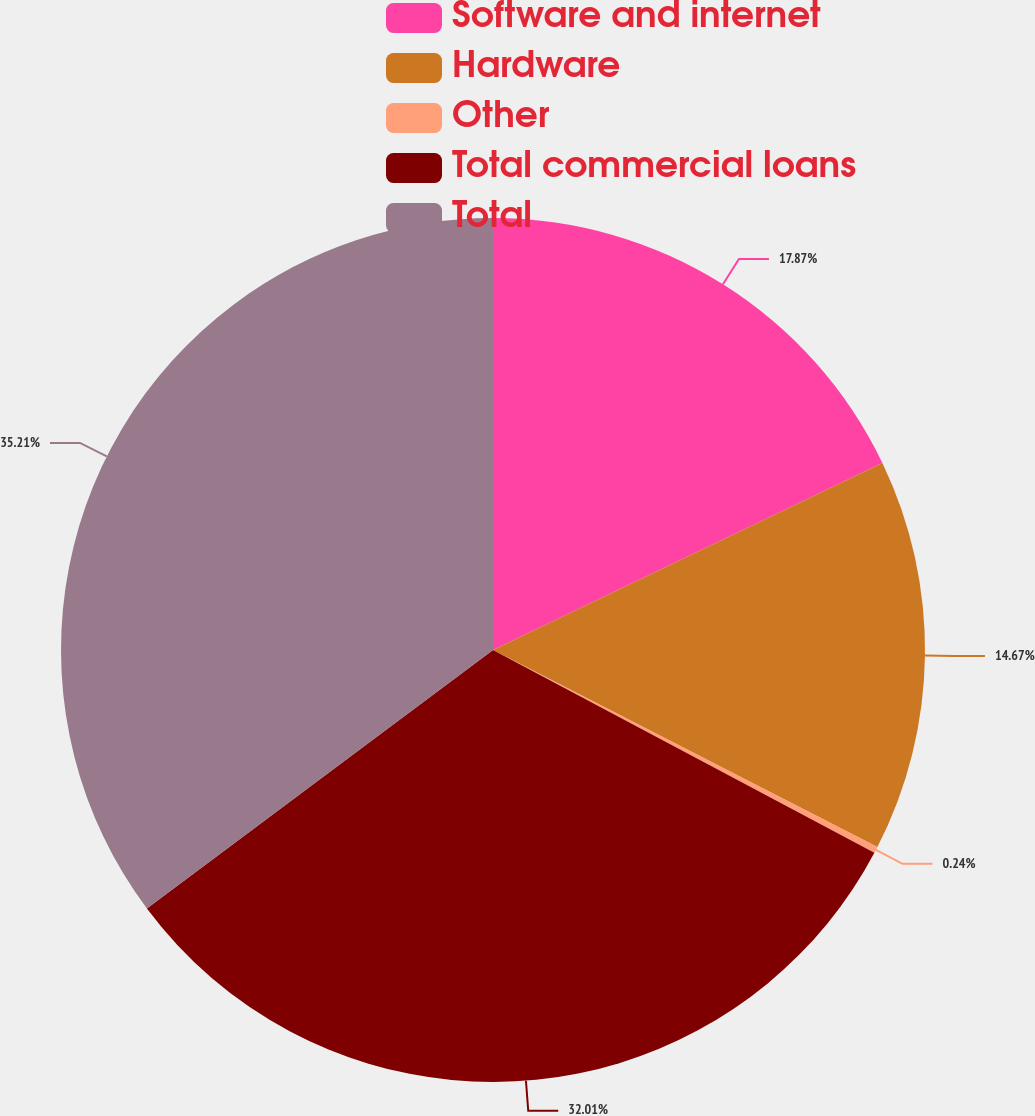Convert chart to OTSL. <chart><loc_0><loc_0><loc_500><loc_500><pie_chart><fcel>Software and internet<fcel>Hardware<fcel>Other<fcel>Total commercial loans<fcel>Total<nl><fcel>17.87%<fcel>14.67%<fcel>0.24%<fcel>32.01%<fcel>35.21%<nl></chart> 